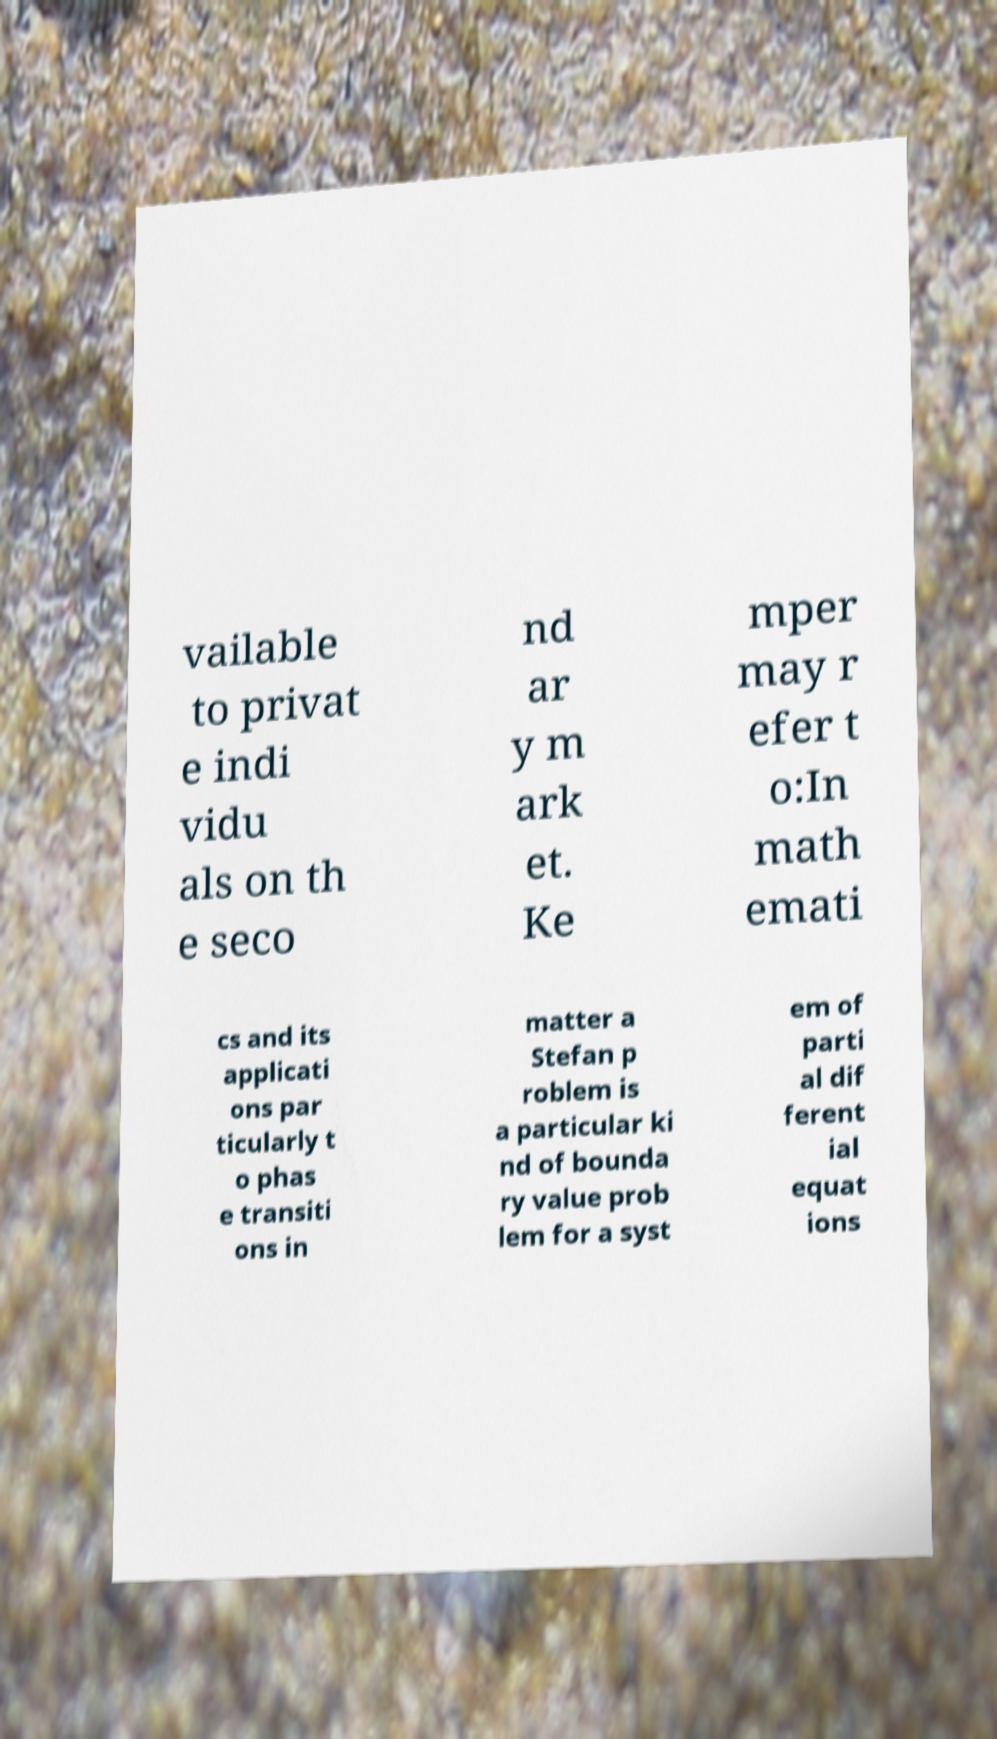Please read and relay the text visible in this image. What does it say? vailable to privat e indi vidu als on th e seco nd ar y m ark et. Ke mper may r efer t o:In math emati cs and its applicati ons par ticularly t o phas e transiti ons in matter a Stefan p roblem is a particular ki nd of bounda ry value prob lem for a syst em of parti al dif ferent ial equat ions 